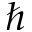<formula> <loc_0><loc_0><loc_500><loc_500>\hbar</formula> 